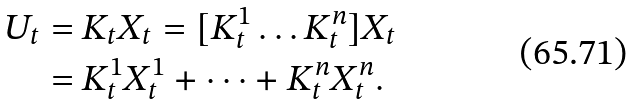Convert formula to latex. <formula><loc_0><loc_0><loc_500><loc_500>U _ { t } & = K _ { t } X _ { t } = [ K ^ { 1 } _ { t } \dots K ^ { n } _ { t } ] X _ { t } \\ & = K ^ { 1 } _ { t } X ^ { 1 } _ { t } + \dots + K ^ { n } _ { t } X ^ { n } _ { t } .</formula> 